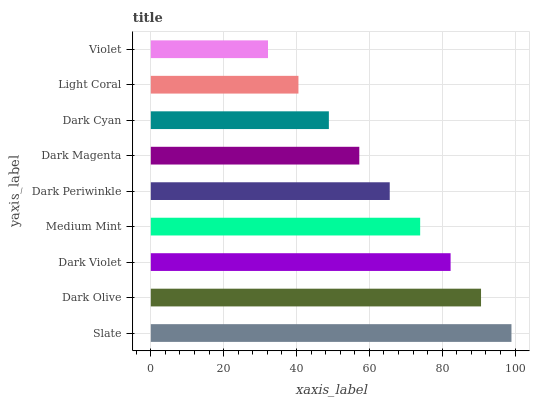Is Violet the minimum?
Answer yes or no. Yes. Is Slate the maximum?
Answer yes or no. Yes. Is Dark Olive the minimum?
Answer yes or no. No. Is Dark Olive the maximum?
Answer yes or no. No. Is Slate greater than Dark Olive?
Answer yes or no. Yes. Is Dark Olive less than Slate?
Answer yes or no. Yes. Is Dark Olive greater than Slate?
Answer yes or no. No. Is Slate less than Dark Olive?
Answer yes or no. No. Is Dark Periwinkle the high median?
Answer yes or no. Yes. Is Dark Periwinkle the low median?
Answer yes or no. Yes. Is Slate the high median?
Answer yes or no. No. Is Slate the low median?
Answer yes or no. No. 